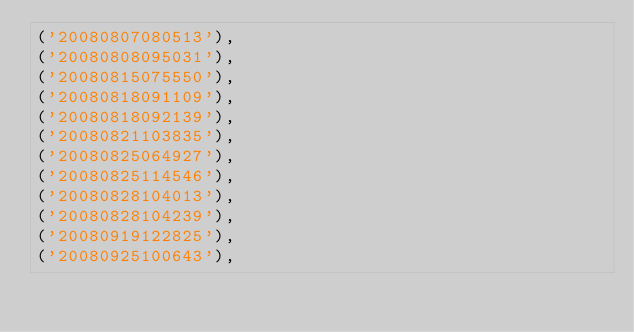Convert code to text. <code><loc_0><loc_0><loc_500><loc_500><_SQL_>('20080807080513'),
('20080808095031'),
('20080815075550'),
('20080818091109'),
('20080818092139'),
('20080821103835'),
('20080825064927'),
('20080825114546'),
('20080828104013'),
('20080828104239'),
('20080919122825'),
('20080925100643'),</code> 